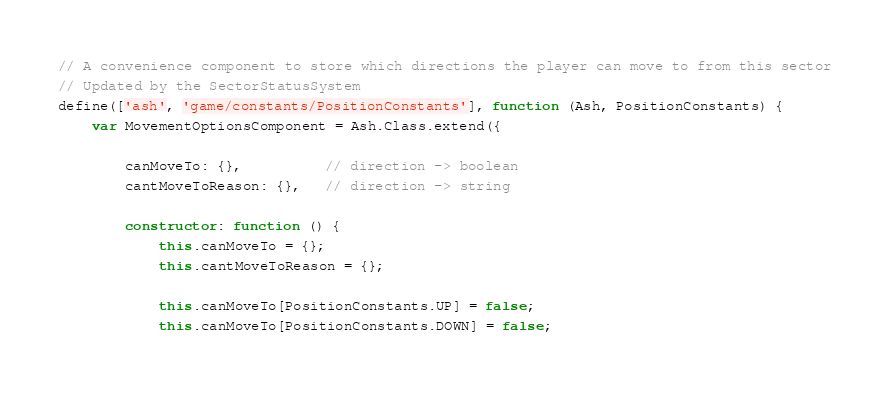<code> <loc_0><loc_0><loc_500><loc_500><_JavaScript_>// A convenience component to store which directions the player can move to from this sector
// Updated by the SectorStatusSystem
define(['ash', 'game/constants/PositionConstants'], function (Ash, PositionConstants) {
	var MovementOptionsComponent = Ash.Class.extend({
		
		canMoveTo: {},          // direction -> boolean
		cantMoveToReason: {},   // direction -> string
		
		constructor: function () {
			this.canMoveTo = {};
			this.cantMoveToReason = {};
			
			this.canMoveTo[PositionConstants.UP] = false;
			this.canMoveTo[PositionConstants.DOWN] = false;
			</code> 